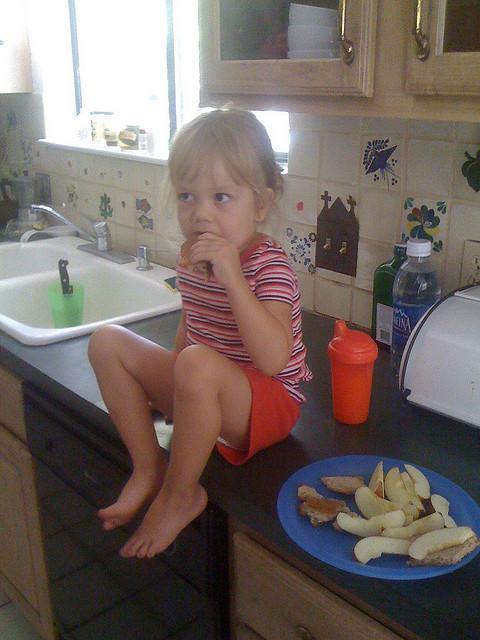What is a danger to the child?
From the following four choices, select the correct answer to address the question.
Options: Sharp knife, snake, poisonous frog, trampoline fall. Sharp knife. 